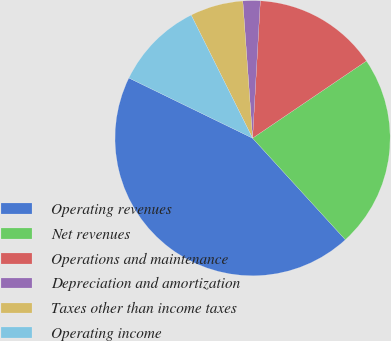<chart> <loc_0><loc_0><loc_500><loc_500><pie_chart><fcel>Operating revenues<fcel>Net revenues<fcel>Operations and maintenance<fcel>Depreciation and amortization<fcel>Taxes other than income taxes<fcel>Operating income<nl><fcel>43.99%<fcel>22.7%<fcel>14.62%<fcel>2.03%<fcel>6.23%<fcel>10.43%<nl></chart> 